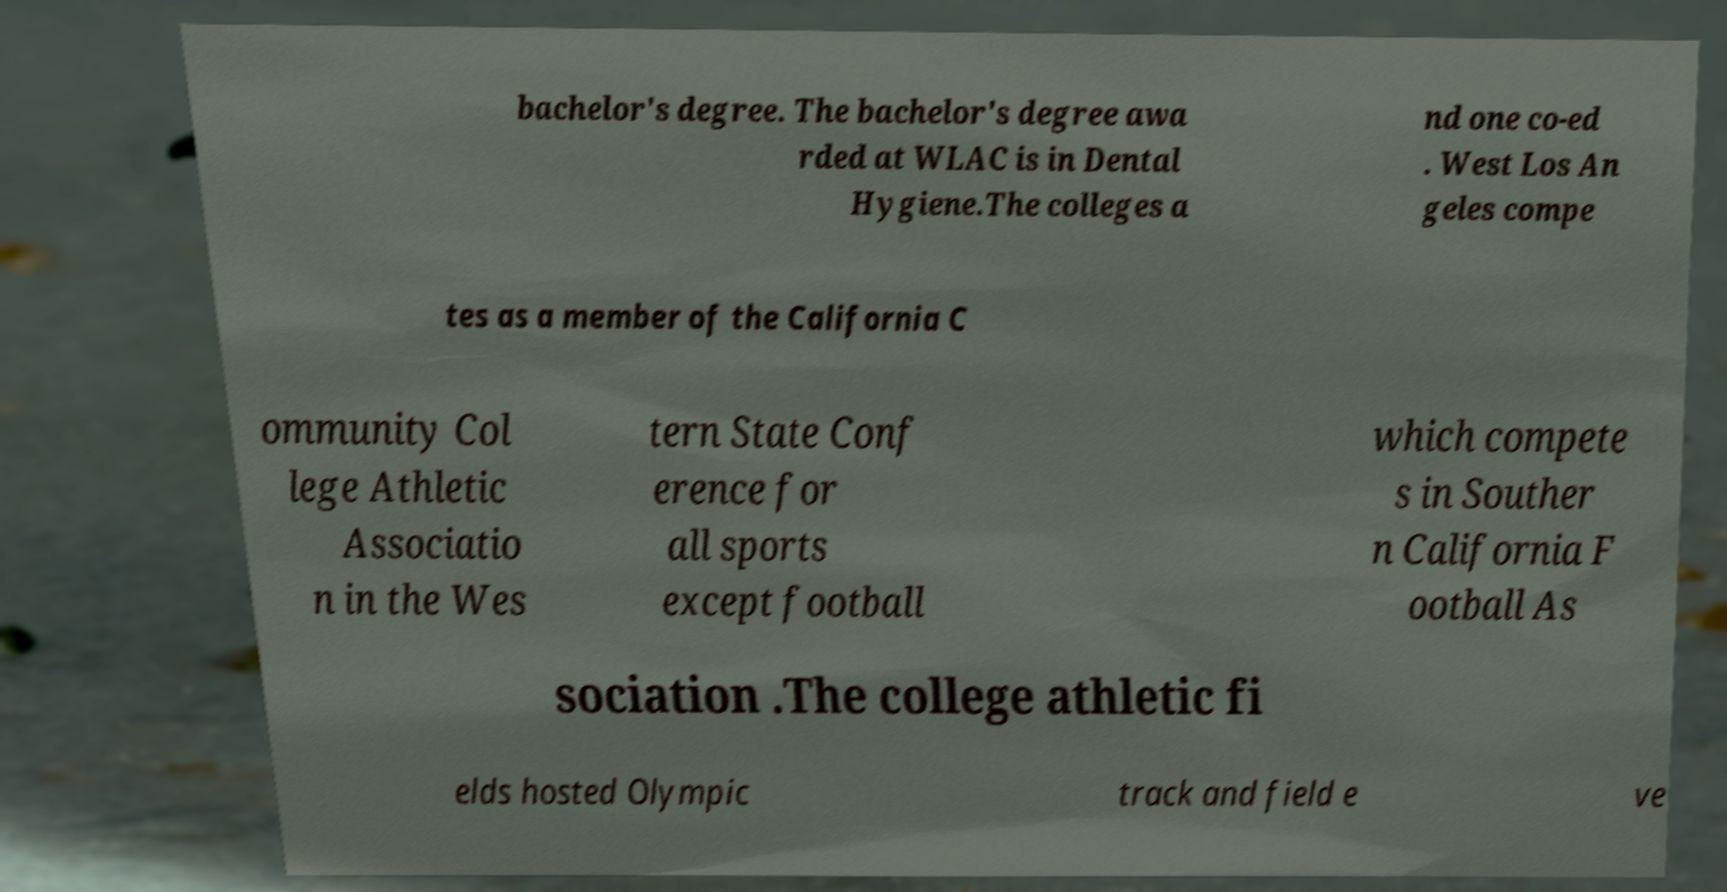Can you accurately transcribe the text from the provided image for me? bachelor's degree. The bachelor's degree awa rded at WLAC is in Dental Hygiene.The colleges a nd one co-ed . West Los An geles compe tes as a member of the California C ommunity Col lege Athletic Associatio n in the Wes tern State Conf erence for all sports except football which compete s in Souther n California F ootball As sociation .The college athletic fi elds hosted Olympic track and field e ve 